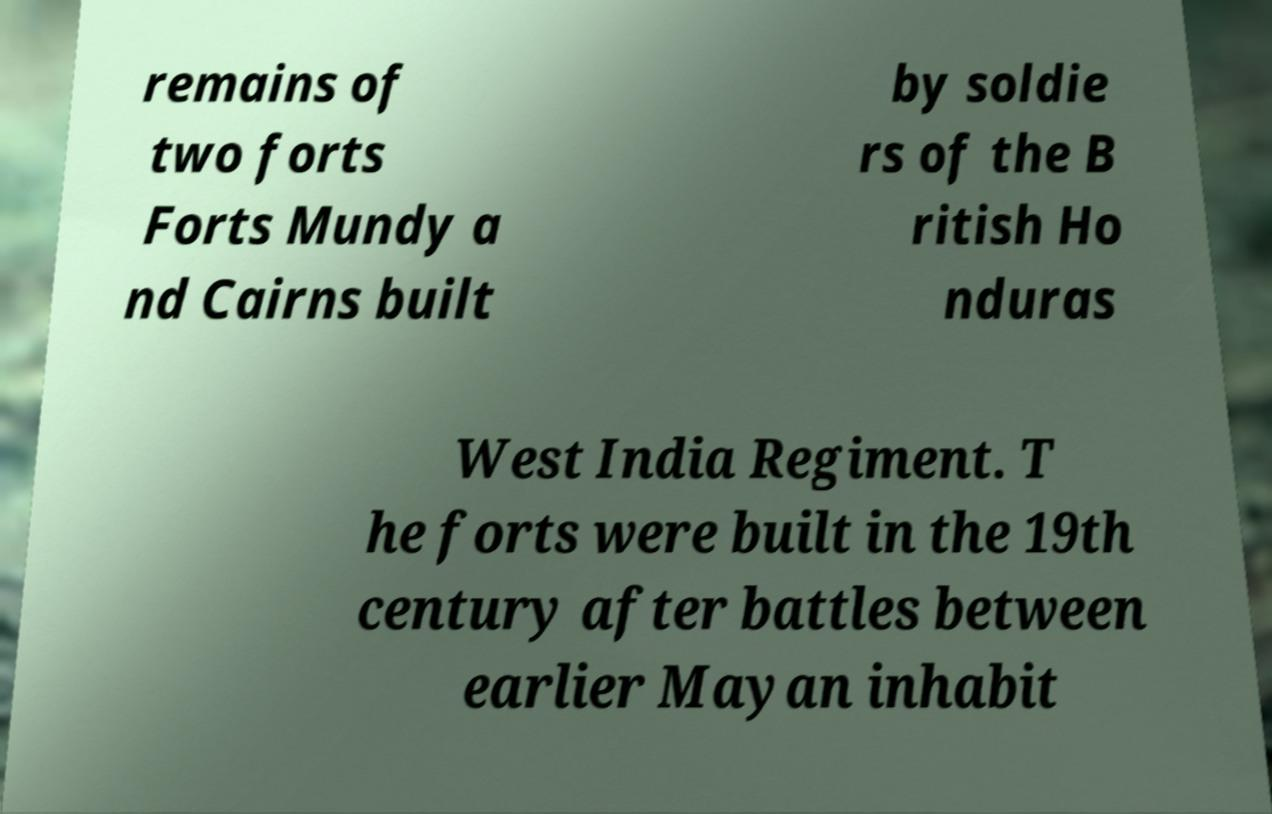There's text embedded in this image that I need extracted. Can you transcribe it verbatim? remains of two forts Forts Mundy a nd Cairns built by soldie rs of the B ritish Ho nduras West India Regiment. T he forts were built in the 19th century after battles between earlier Mayan inhabit 